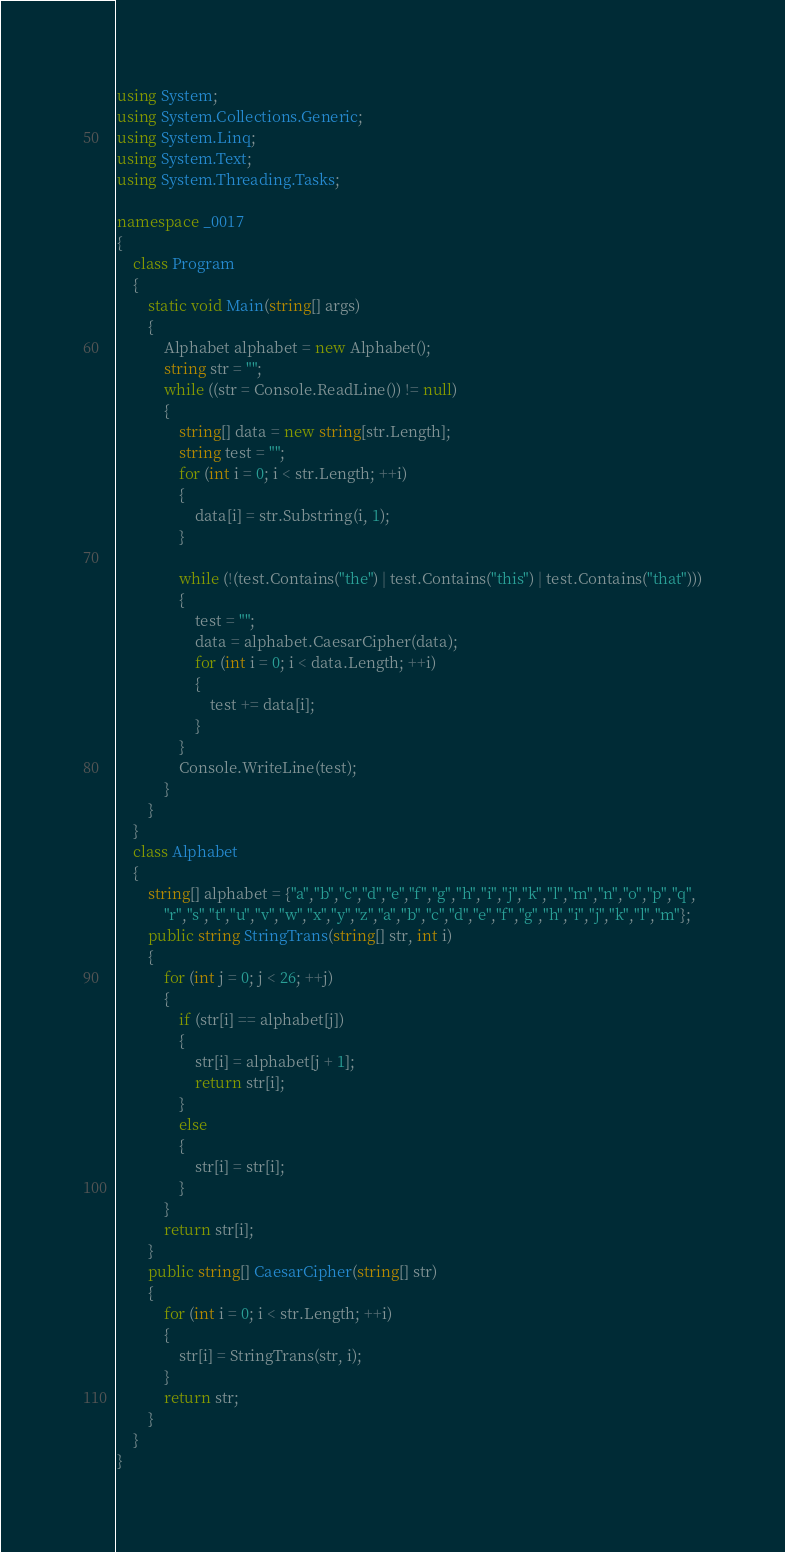<code> <loc_0><loc_0><loc_500><loc_500><_C#_>using System;
using System.Collections.Generic;
using System.Linq;
using System.Text;
using System.Threading.Tasks;

namespace _0017
{
    class Program
    {
        static void Main(string[] args)
        {
            Alphabet alphabet = new Alphabet();
            string str = "";
            while ((str = Console.ReadLine()) != null)
            {
                string[] data = new string[str.Length];
                string test = "";
                for (int i = 0; i < str.Length; ++i)
                {
                    data[i] = str.Substring(i, 1);
                }
              
                while (!(test.Contains("the") | test.Contains("this") | test.Contains("that")))
                {
                    test = "";
                    data = alphabet.CaesarCipher(data);
                    for (int i = 0; i < data.Length; ++i)
                    {
                        test += data[i];
                    }
                }
                Console.WriteLine(test);
            }
        }
    }
    class Alphabet
    {
        string[] alphabet = {"a","b","c","d","e","f","g","h","i","j","k","l","m","n","o","p","q",
            "r","s","t","u","v","w","x","y","z","a","b","c","d","e","f","g","h","i","j","k","l","m"};
        public string StringTrans(string[] str, int i)
        {
            for (int j = 0; j < 26; ++j)
            {
                if (str[i] == alphabet[j])
                {
                    str[i] = alphabet[j + 1];
                    return str[i];
                }
                else
                {
                    str[i] = str[i];
                }
            }
            return str[i];
        }
        public string[] CaesarCipher(string[] str)
        {
            for (int i = 0; i < str.Length; ++i)
            {
                str[i] = StringTrans(str, i);
            }
            return str;
        }
    }
}

</code> 